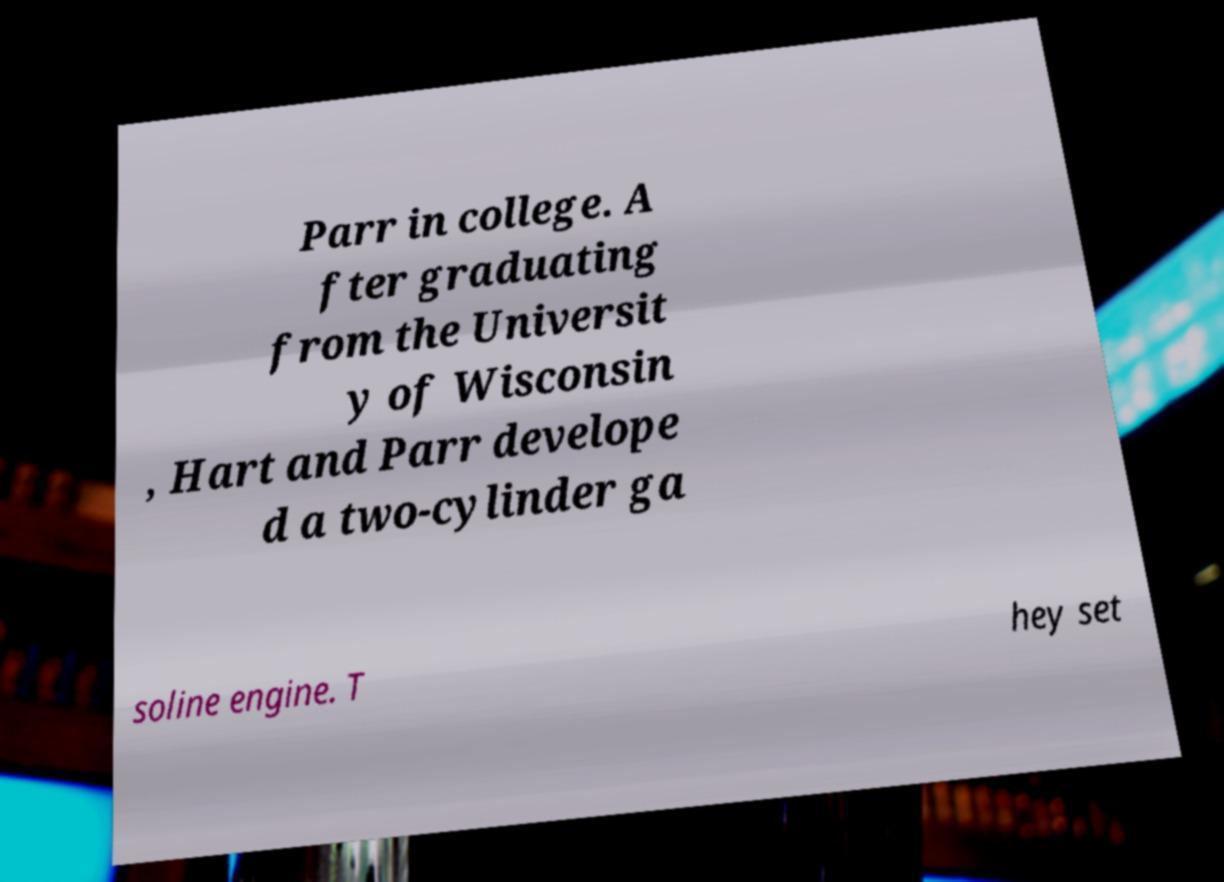Could you assist in decoding the text presented in this image and type it out clearly? Parr in college. A fter graduating from the Universit y of Wisconsin , Hart and Parr develope d a two-cylinder ga soline engine. T hey set 